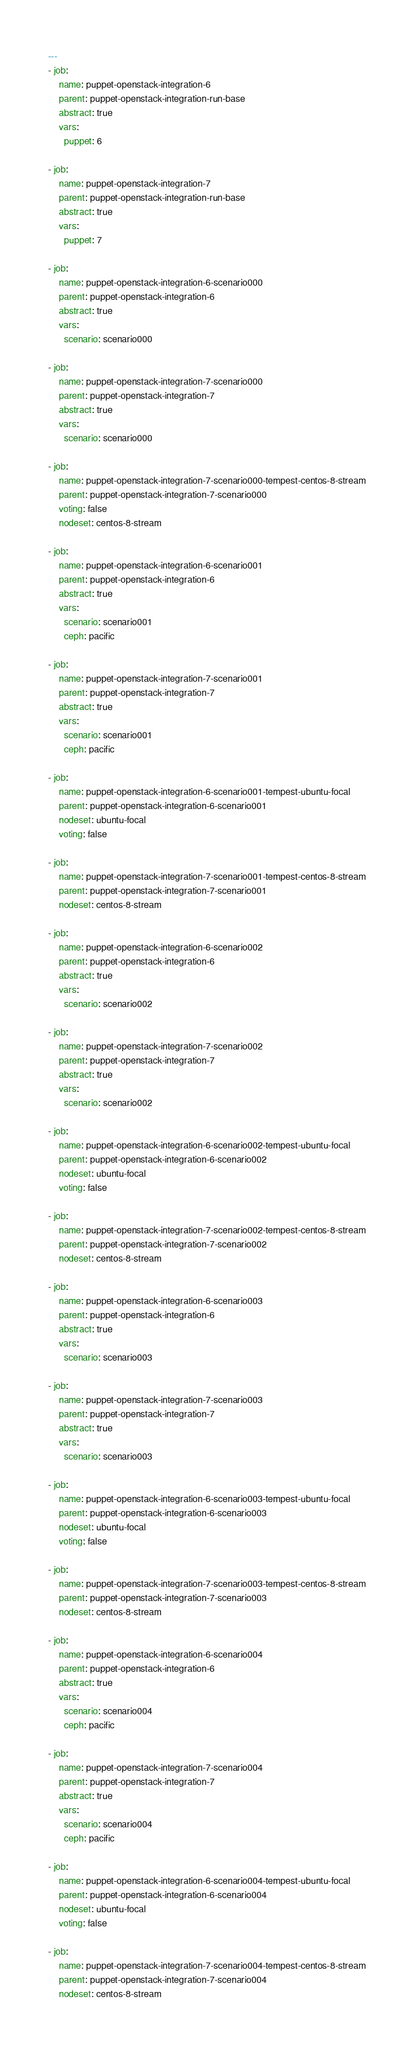Convert code to text. <code><loc_0><loc_0><loc_500><loc_500><_YAML_>---
- job:
    name: puppet-openstack-integration-6
    parent: puppet-openstack-integration-run-base
    abstract: true
    vars:
      puppet: 6

- job:
    name: puppet-openstack-integration-7
    parent: puppet-openstack-integration-run-base
    abstract: true
    vars:
      puppet: 7

- job:
    name: puppet-openstack-integration-6-scenario000
    parent: puppet-openstack-integration-6
    abstract: true
    vars:
      scenario: scenario000

- job:
    name: puppet-openstack-integration-7-scenario000
    parent: puppet-openstack-integration-7
    abstract: true
    vars:
      scenario: scenario000

- job:
    name: puppet-openstack-integration-7-scenario000-tempest-centos-8-stream
    parent: puppet-openstack-integration-7-scenario000
    voting: false
    nodeset: centos-8-stream

- job:
    name: puppet-openstack-integration-6-scenario001
    parent: puppet-openstack-integration-6
    abstract: true
    vars:
      scenario: scenario001
      ceph: pacific

- job:
    name: puppet-openstack-integration-7-scenario001
    parent: puppet-openstack-integration-7
    abstract: true
    vars:
      scenario: scenario001
      ceph: pacific

- job:
    name: puppet-openstack-integration-6-scenario001-tempest-ubuntu-focal
    parent: puppet-openstack-integration-6-scenario001
    nodeset: ubuntu-focal
    voting: false

- job:
    name: puppet-openstack-integration-7-scenario001-tempest-centos-8-stream
    parent: puppet-openstack-integration-7-scenario001
    nodeset: centos-8-stream

- job:
    name: puppet-openstack-integration-6-scenario002
    parent: puppet-openstack-integration-6
    abstract: true
    vars:
      scenario: scenario002

- job:
    name: puppet-openstack-integration-7-scenario002
    parent: puppet-openstack-integration-7
    abstract: true
    vars:
      scenario: scenario002

- job:
    name: puppet-openstack-integration-6-scenario002-tempest-ubuntu-focal
    parent: puppet-openstack-integration-6-scenario002
    nodeset: ubuntu-focal
    voting: false

- job:
    name: puppet-openstack-integration-7-scenario002-tempest-centos-8-stream
    parent: puppet-openstack-integration-7-scenario002
    nodeset: centos-8-stream

- job:
    name: puppet-openstack-integration-6-scenario003
    parent: puppet-openstack-integration-6
    abstract: true
    vars:
      scenario: scenario003

- job:
    name: puppet-openstack-integration-7-scenario003
    parent: puppet-openstack-integration-7
    abstract: true
    vars:
      scenario: scenario003

- job:
    name: puppet-openstack-integration-6-scenario003-tempest-ubuntu-focal
    parent: puppet-openstack-integration-6-scenario003
    nodeset: ubuntu-focal
    voting: false

- job:
    name: puppet-openstack-integration-7-scenario003-tempest-centos-8-stream
    parent: puppet-openstack-integration-7-scenario003
    nodeset: centos-8-stream

- job:
    name: puppet-openstack-integration-6-scenario004
    parent: puppet-openstack-integration-6
    abstract: true
    vars:
      scenario: scenario004
      ceph: pacific

- job:
    name: puppet-openstack-integration-7-scenario004
    parent: puppet-openstack-integration-7
    abstract: true
    vars:
      scenario: scenario004
      ceph: pacific

- job:
    name: puppet-openstack-integration-6-scenario004-tempest-ubuntu-focal
    parent: puppet-openstack-integration-6-scenario004
    nodeset: ubuntu-focal
    voting: false

- job:
    name: puppet-openstack-integration-7-scenario004-tempest-centos-8-stream
    parent: puppet-openstack-integration-7-scenario004
    nodeset: centos-8-stream
</code> 